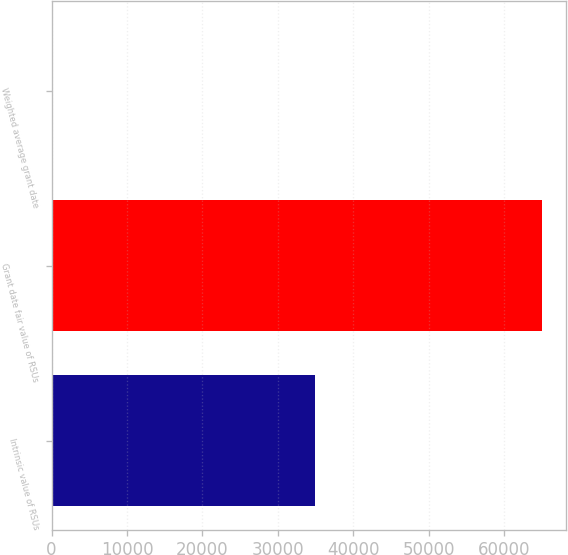Convert chart. <chart><loc_0><loc_0><loc_500><loc_500><bar_chart><fcel>Intrinsic value of RSUs<fcel>Grant date fair value of RSUs<fcel>Weighted average grant date<nl><fcel>34868<fcel>64973<fcel>10.36<nl></chart> 